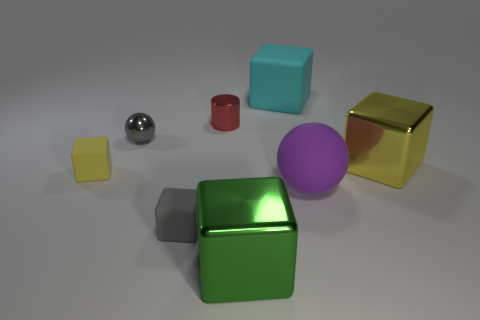What is the material of the purple object that is the same size as the green metallic thing? rubber 